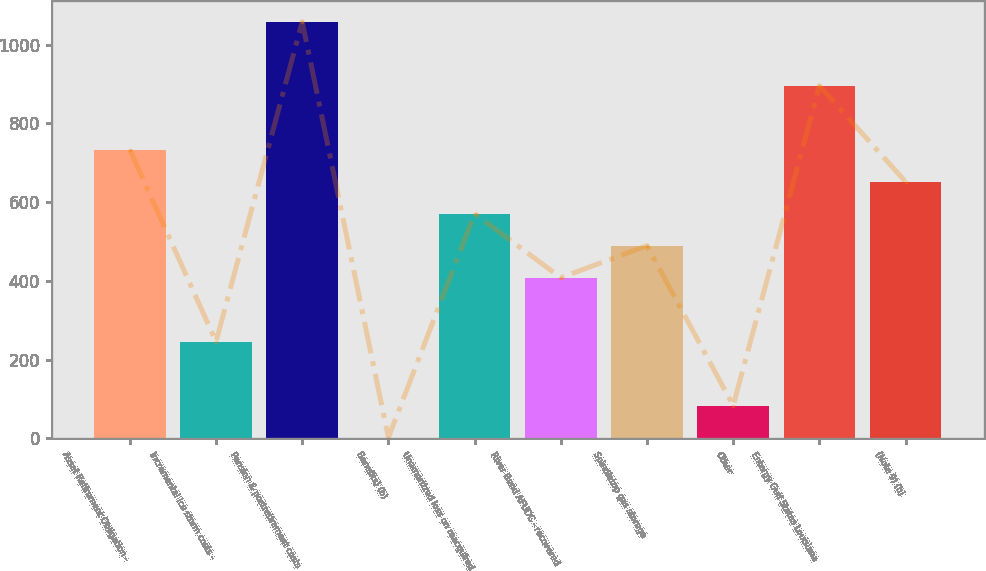Convert chart. <chart><loc_0><loc_0><loc_500><loc_500><bar_chart><fcel>Asset Retirement Obligation -<fcel>Incremental ice storm costs -<fcel>Pension & postretirement costs<fcel>Benefits) (b)<fcel>Unamortized loss on reacquired<fcel>River Bend AFUDC - recovered<fcel>Spindletop gas storage<fcel>Other<fcel>Entergy Gulf States Louisiana<fcel>(Note 9) (b)<nl><fcel>733.29<fcel>246.03<fcel>1058.13<fcel>2.4<fcel>570.87<fcel>408.45<fcel>489.66<fcel>83.61<fcel>895.71<fcel>652.08<nl></chart> 